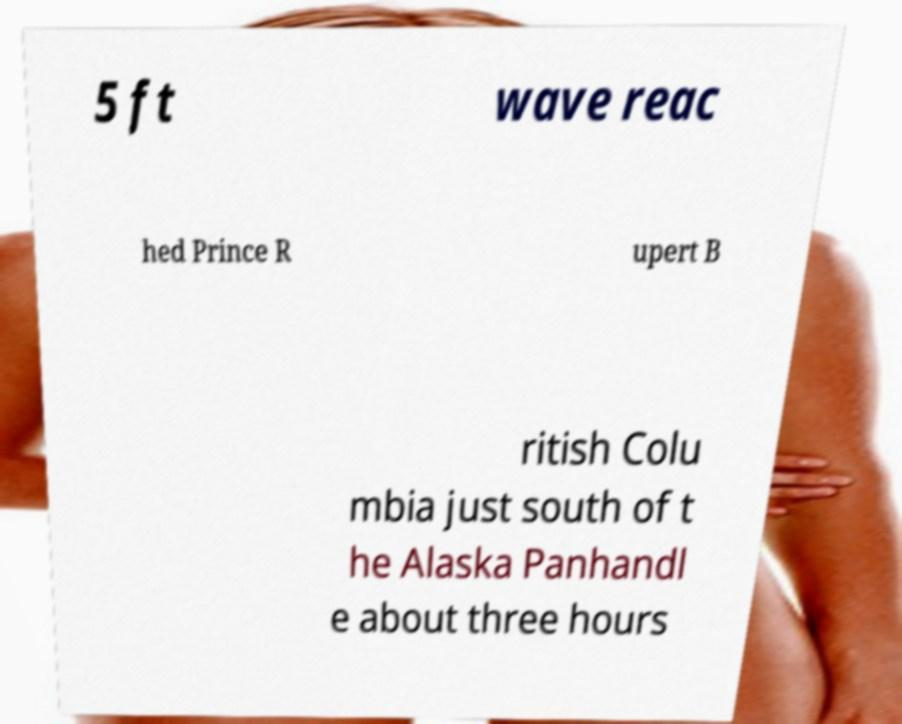For documentation purposes, I need the text within this image transcribed. Could you provide that? 5 ft wave reac hed Prince R upert B ritish Colu mbia just south of t he Alaska Panhandl e about three hours 